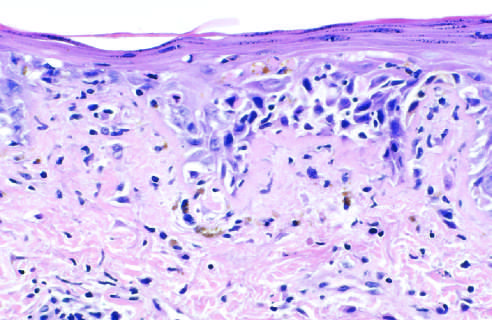does the immediate reaction show liquefactive degeneration of the basal layer of the epidermis and edema at the dermoepidermal junction?
Answer the question using a single word or phrase. No 